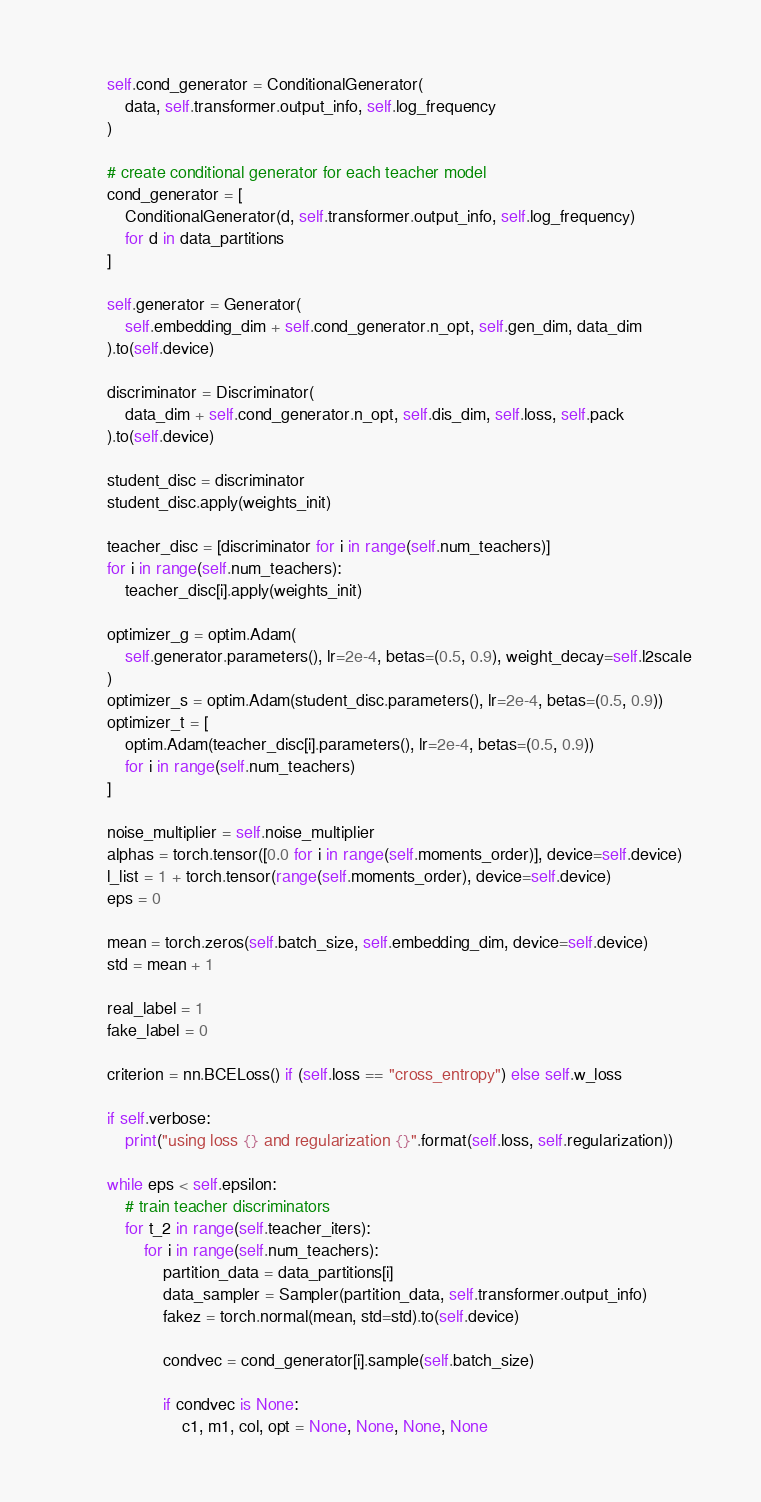Convert code to text. <code><loc_0><loc_0><loc_500><loc_500><_Python_>        self.cond_generator = ConditionalGenerator(
            data, self.transformer.output_info, self.log_frequency
        )

        # create conditional generator for each teacher model
        cond_generator = [
            ConditionalGenerator(d, self.transformer.output_info, self.log_frequency)
            for d in data_partitions
        ]

        self.generator = Generator(
            self.embedding_dim + self.cond_generator.n_opt, self.gen_dim, data_dim
        ).to(self.device)

        discriminator = Discriminator(
            data_dim + self.cond_generator.n_opt, self.dis_dim, self.loss, self.pack
        ).to(self.device)

        student_disc = discriminator
        student_disc.apply(weights_init)

        teacher_disc = [discriminator for i in range(self.num_teachers)]
        for i in range(self.num_teachers):
            teacher_disc[i].apply(weights_init)

        optimizer_g = optim.Adam(
            self.generator.parameters(), lr=2e-4, betas=(0.5, 0.9), weight_decay=self.l2scale
        )
        optimizer_s = optim.Adam(student_disc.parameters(), lr=2e-4, betas=(0.5, 0.9))
        optimizer_t = [
            optim.Adam(teacher_disc[i].parameters(), lr=2e-4, betas=(0.5, 0.9))
            for i in range(self.num_teachers)
        ]

        noise_multiplier = self.noise_multiplier
        alphas = torch.tensor([0.0 for i in range(self.moments_order)], device=self.device)
        l_list = 1 + torch.tensor(range(self.moments_order), device=self.device)
        eps = 0

        mean = torch.zeros(self.batch_size, self.embedding_dim, device=self.device)
        std = mean + 1

        real_label = 1
        fake_label = 0

        criterion = nn.BCELoss() if (self.loss == "cross_entropy") else self.w_loss

        if self.verbose:
            print("using loss {} and regularization {}".format(self.loss, self.regularization))

        while eps < self.epsilon:
            # train teacher discriminators
            for t_2 in range(self.teacher_iters):
                for i in range(self.num_teachers):
                    partition_data = data_partitions[i]
                    data_sampler = Sampler(partition_data, self.transformer.output_info)
                    fakez = torch.normal(mean, std=std).to(self.device)

                    condvec = cond_generator[i].sample(self.batch_size)

                    if condvec is None:
                        c1, m1, col, opt = None, None, None, None</code> 